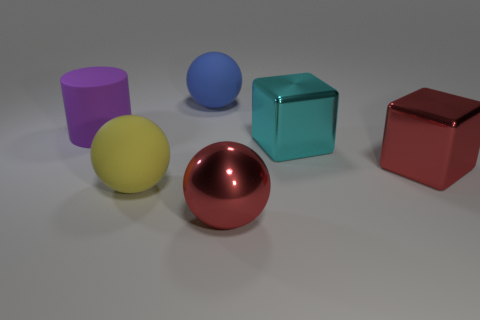Subtract all big rubber balls. How many balls are left? 1 Add 3 big rubber things. How many objects exist? 9 Subtract all red cubes. How many cubes are left? 1 Subtract 0 cyan spheres. How many objects are left? 6 Subtract all cylinders. How many objects are left? 5 Subtract 1 cylinders. How many cylinders are left? 0 Subtract all purple balls. Subtract all brown blocks. How many balls are left? 3 Subtract all blue cylinders. How many purple blocks are left? 0 Subtract all big matte things. Subtract all large cyan objects. How many objects are left? 2 Add 2 large purple cylinders. How many large purple cylinders are left? 3 